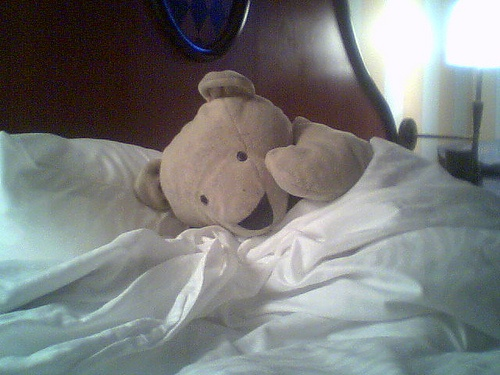Describe the objects in this image and their specific colors. I can see bed in darkgray, gray, and black tones and teddy bear in black, gray, and darkgray tones in this image. 